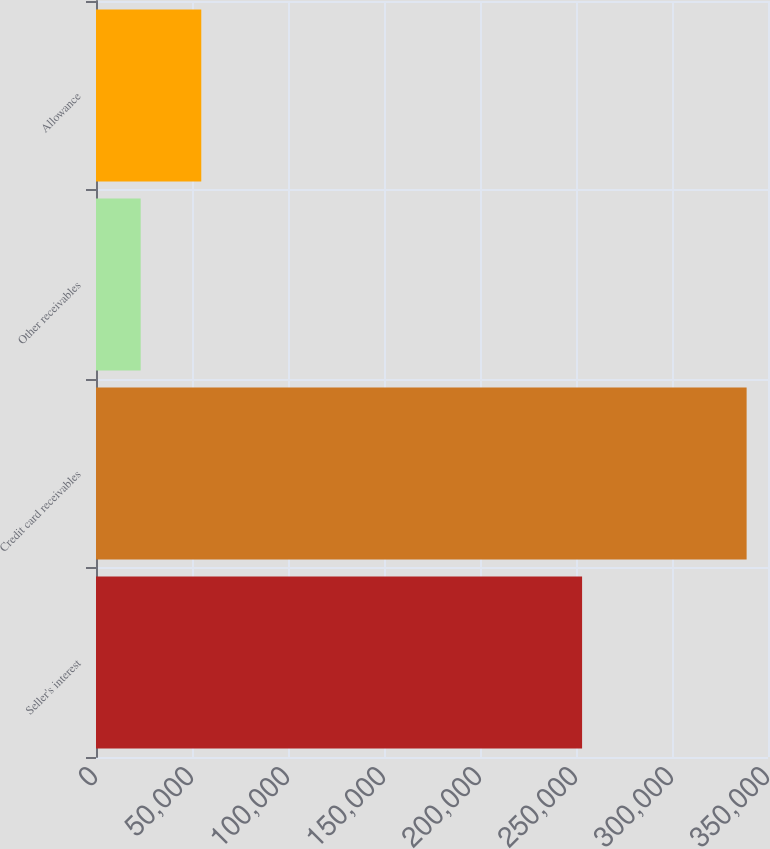Convert chart. <chart><loc_0><loc_0><loc_500><loc_500><bar_chart><fcel>Seller's interest<fcel>Credit card receivables<fcel>Other receivables<fcel>Allowance<nl><fcel>253170<fcel>338864<fcel>23274<fcel>54833<nl></chart> 